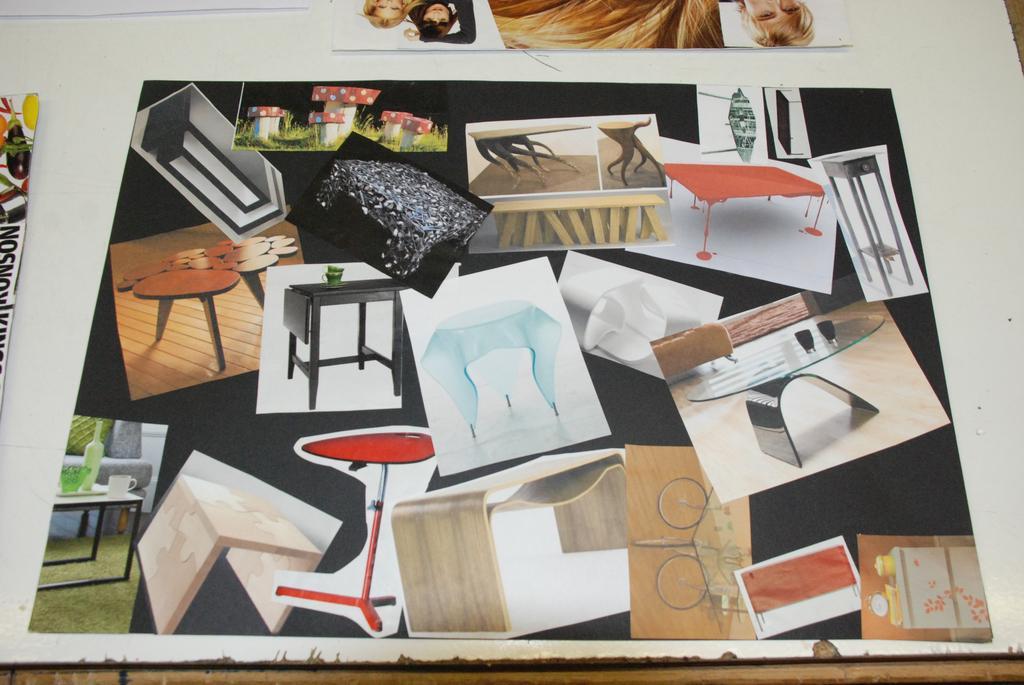Please provide a concise description of this image. In this image we can see photos of several tables are placed on the table. 